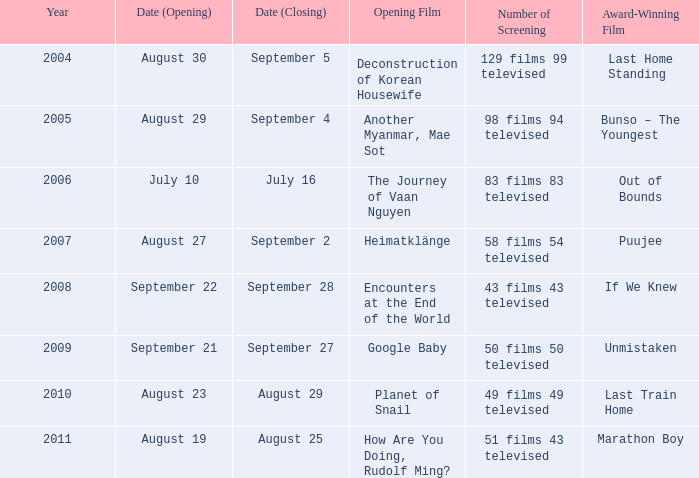How many screenings were held for the opening film, the journey of vaan nguyen? 1.0. 